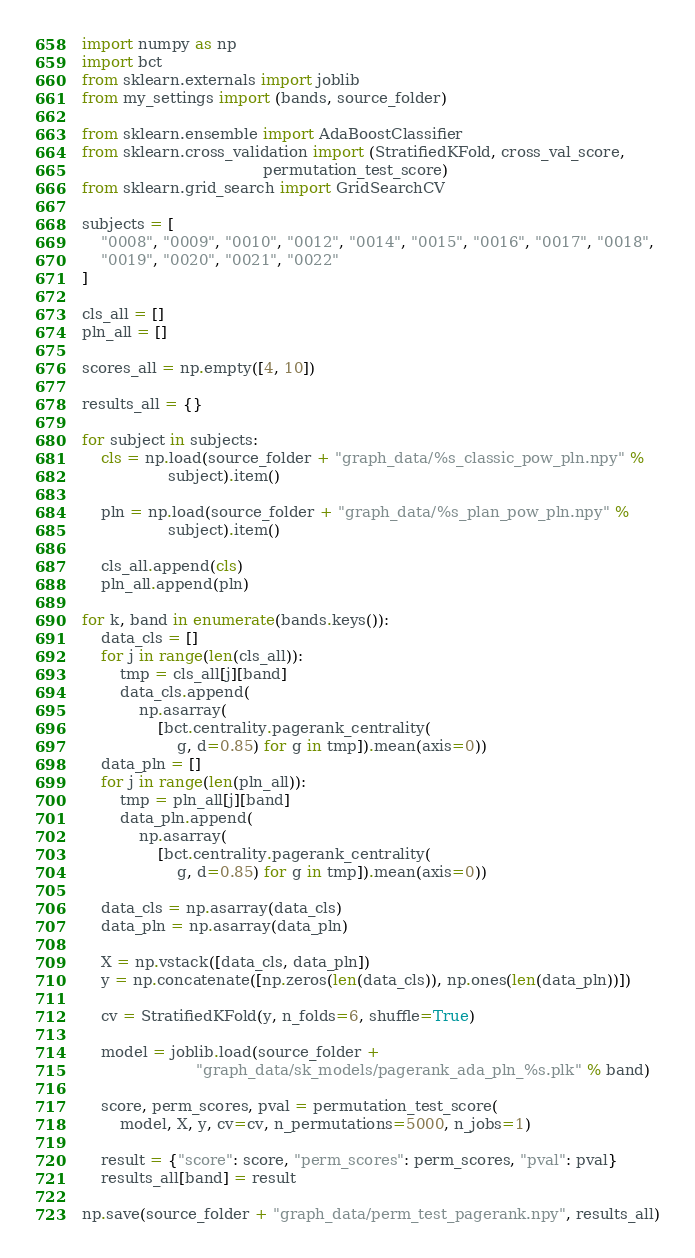<code> <loc_0><loc_0><loc_500><loc_500><_Python_>import numpy as np
import bct
from sklearn.externals import joblib
from my_settings import (bands, source_folder)

from sklearn.ensemble import AdaBoostClassifier
from sklearn.cross_validation import (StratifiedKFold, cross_val_score,
                                      permutation_test_score)
from sklearn.grid_search import GridSearchCV

subjects = [
    "0008", "0009", "0010", "0012", "0014", "0015", "0016", "0017", "0018",
    "0019", "0020", "0021", "0022"
]

cls_all = []
pln_all = []

scores_all = np.empty([4, 10])

results_all = {}

for subject in subjects:
    cls = np.load(source_folder + "graph_data/%s_classic_pow_pln.npy" %
                  subject).item()

    pln = np.load(source_folder + "graph_data/%s_plan_pow_pln.npy" %
                  subject).item()

    cls_all.append(cls)
    pln_all.append(pln)

for k, band in enumerate(bands.keys()):
    data_cls = []
    for j in range(len(cls_all)):
        tmp = cls_all[j][band]
        data_cls.append(
            np.asarray(
                [bct.centrality.pagerank_centrality(
                    g, d=0.85) for g in tmp]).mean(axis=0))
    data_pln = []
    for j in range(len(pln_all)):
        tmp = pln_all[j][band]
        data_pln.append(
            np.asarray(
                [bct.centrality.pagerank_centrality(
                    g, d=0.85) for g in tmp]).mean(axis=0))

    data_cls = np.asarray(data_cls)
    data_pln = np.asarray(data_pln)

    X = np.vstack([data_cls, data_pln])
    y = np.concatenate([np.zeros(len(data_cls)), np.ones(len(data_pln))])

    cv = StratifiedKFold(y, n_folds=6, shuffle=True)

    model = joblib.load(source_folder +
                        "graph_data/sk_models/pagerank_ada_pln_%s.plk" % band)

    score, perm_scores, pval = permutation_test_score(
        model, X, y, cv=cv, n_permutations=5000, n_jobs=1)

    result = {"score": score, "perm_scores": perm_scores, "pval": pval}
    results_all[band] = result

np.save(source_folder + "graph_data/perm_test_pagerank.npy", results_all)
</code> 